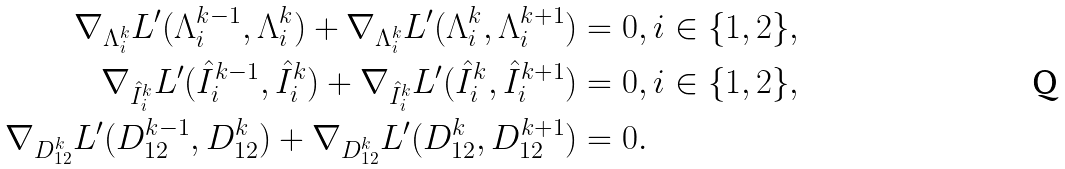Convert formula to latex. <formula><loc_0><loc_0><loc_500><loc_500>\nabla _ { \Lambda _ { i } ^ { k } } L ^ { \prime } ( \Lambda _ { i } ^ { k - 1 } , \Lambda _ { i } ^ { k } ) + \nabla _ { \Lambda _ { i } ^ { k } } L ^ { \prime } ( \Lambda _ { i } ^ { k } , \Lambda _ { i } ^ { k + 1 } ) & = 0 , i \in \{ 1 , 2 \} , \\ \nabla _ { \hat { I } _ { i } ^ { k } } L ^ { \prime } ( \hat { I } _ { i } ^ { k - 1 } , \hat { I } _ { i } ^ { k } ) + \nabla _ { \hat { I } _ { i } ^ { k } } L ^ { \prime } ( \hat { I } _ { i } ^ { k } , \hat { I } _ { i } ^ { k + 1 } ) & = 0 , i \in \{ 1 , 2 \} , \\ \nabla _ { D _ { 1 2 } ^ { k } } L ^ { \prime } ( D _ { 1 2 } ^ { k - 1 } , D _ { 1 2 } ^ { k } ) + \nabla _ { D _ { 1 2 } ^ { k } } L ^ { \prime } ( D _ { 1 2 } ^ { k } , D _ { 1 2 } ^ { k + 1 } ) & = 0 . \\</formula> 